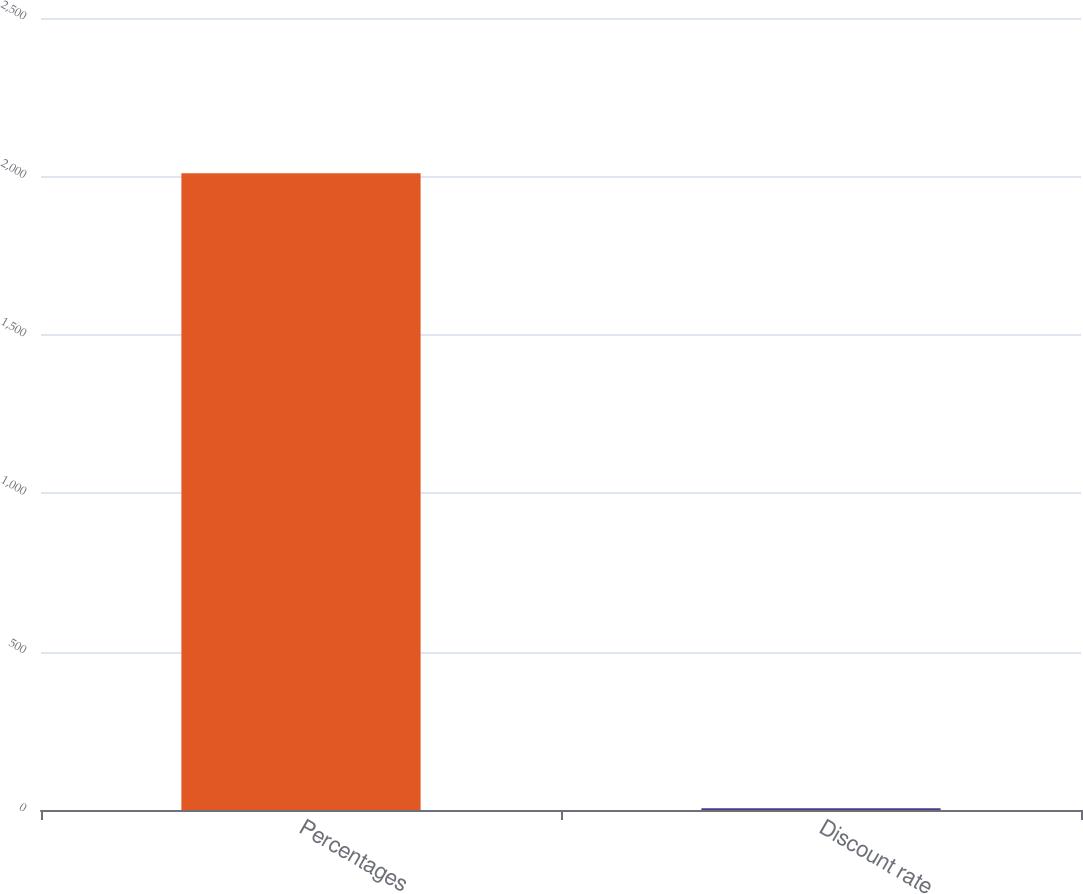Convert chart. <chart><loc_0><loc_0><loc_500><loc_500><bar_chart><fcel>Percentages<fcel>Discount rate<nl><fcel>2010<fcel>5.9<nl></chart> 